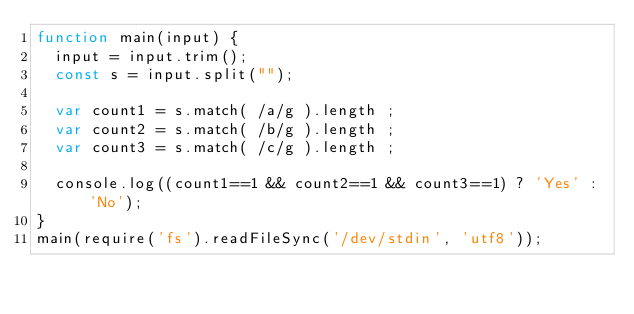Convert code to text. <code><loc_0><loc_0><loc_500><loc_500><_JavaScript_>function main(input) {
  input = input.trim();
  const s = input.split("");
 
  var count1 = s.match( /a/g ).length ;
  var count2 = s.match( /b/g ).length ;
  var count3 = s.match( /c/g ).length ;
  
  console.log((count1==1 && count2==1 && count3==1) ? 'Yes' : 'No');
}
main(require('fs').readFileSync('/dev/stdin', 'utf8'));</code> 